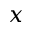Convert formula to latex. <formula><loc_0><loc_0><loc_500><loc_500>x</formula> 